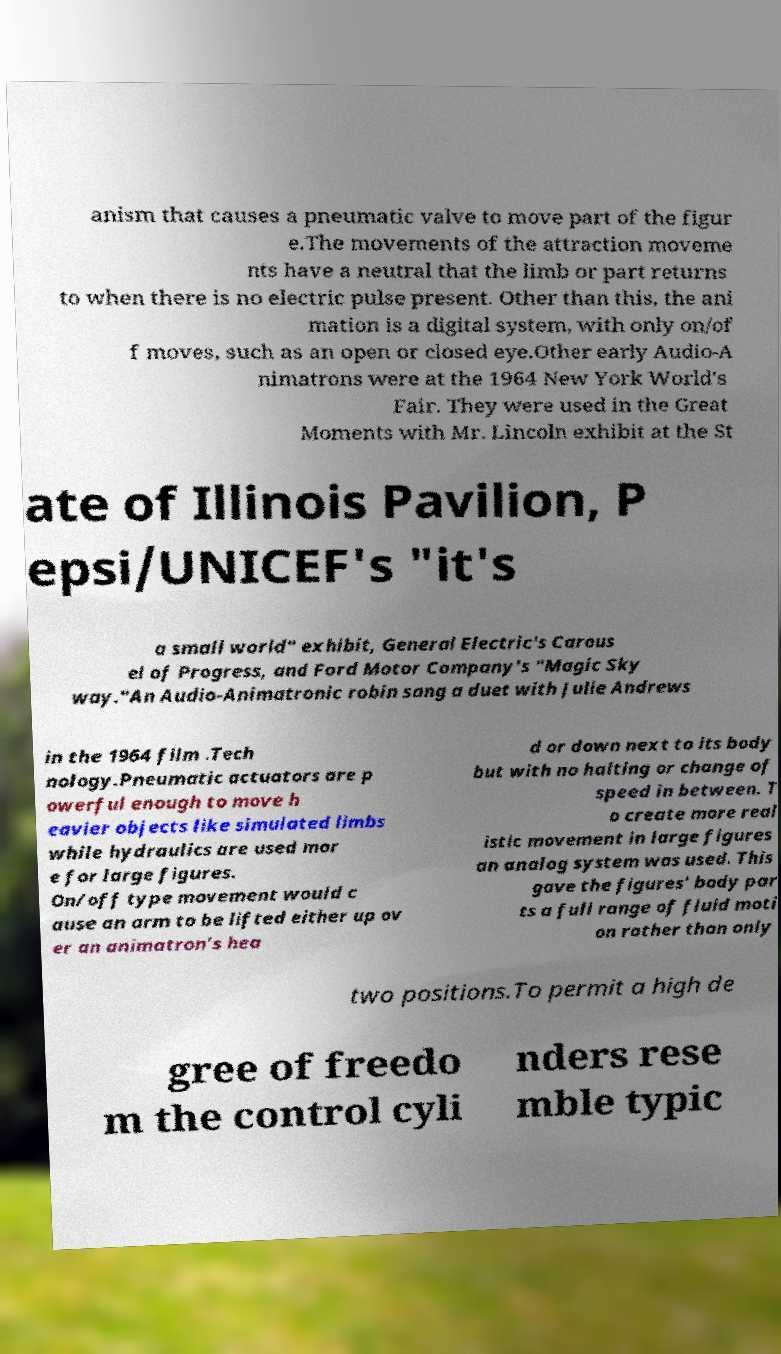Could you assist in decoding the text presented in this image and type it out clearly? anism that causes a pneumatic valve to move part of the figur e.The movements of the attraction moveme nts have a neutral that the limb or part returns to when there is no electric pulse present. Other than this, the ani mation is a digital system, with only on/of f moves, such as an open or closed eye.Other early Audio-A nimatrons were at the 1964 New York World's Fair. They were used in the Great Moments with Mr. Lincoln exhibit at the St ate of Illinois Pavilion, P epsi/UNICEF's "it's a small world" exhibit, General Electric's Carous el of Progress, and Ford Motor Company's "Magic Sky way."An Audio-Animatronic robin sang a duet with Julie Andrews in the 1964 film .Tech nology.Pneumatic actuators are p owerful enough to move h eavier objects like simulated limbs while hydraulics are used mor e for large figures. On/off type movement would c ause an arm to be lifted either up ov er an animatron's hea d or down next to its body but with no halting or change of speed in between. T o create more real istic movement in large figures an analog system was used. This gave the figures' body par ts a full range of fluid moti on rather than only two positions.To permit a high de gree of freedo m the control cyli nders rese mble typic 